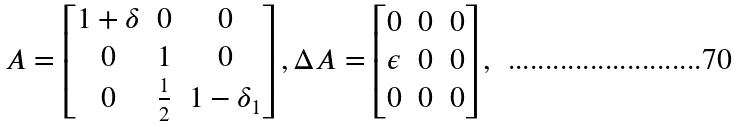<formula> <loc_0><loc_0><loc_500><loc_500>A = \left [ \begin{matrix} 1 + \delta & 0 & 0 \\ 0 & 1 & 0 \\ 0 & \frac { 1 } { 2 } & 1 - \delta _ { 1 } \end{matrix} \right ] , \Delta A = \left [ \begin{matrix} 0 & 0 & 0 \\ \epsilon & 0 & 0 \\ 0 & 0 & 0 \end{matrix} \right ] ,</formula> 